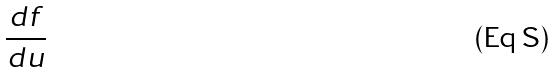Convert formula to latex. <formula><loc_0><loc_0><loc_500><loc_500>\frac { d f } { d u }</formula> 